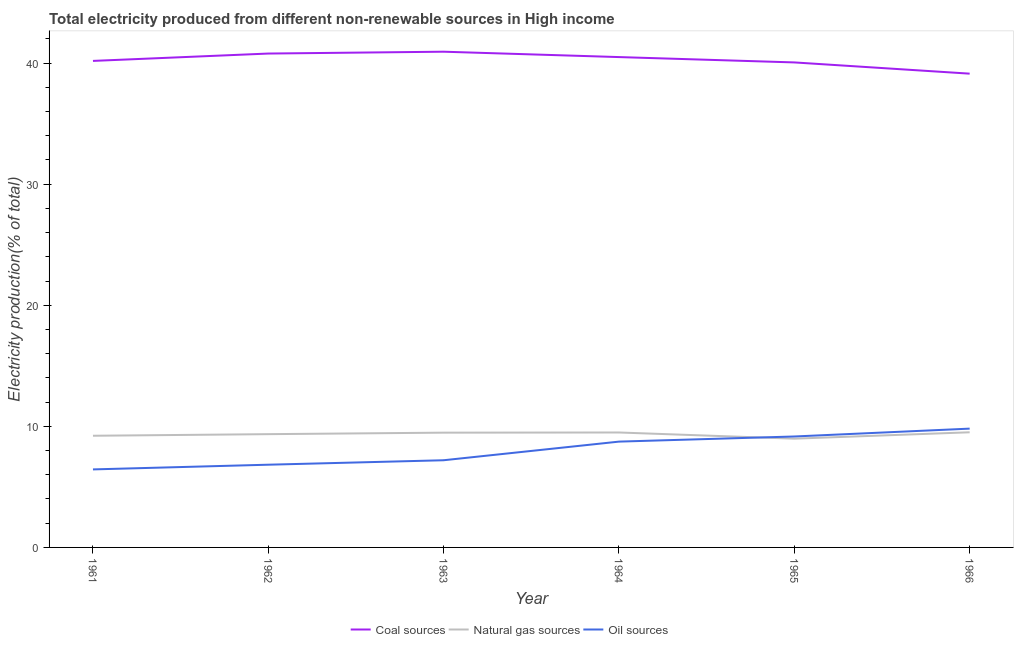What is the percentage of electricity produced by oil sources in 1964?
Your answer should be compact. 8.74. Across all years, what is the maximum percentage of electricity produced by natural gas?
Your answer should be compact. 9.51. Across all years, what is the minimum percentage of electricity produced by coal?
Your answer should be compact. 39.13. In which year was the percentage of electricity produced by coal maximum?
Offer a very short reply. 1963. In which year was the percentage of electricity produced by coal minimum?
Keep it short and to the point. 1966. What is the total percentage of electricity produced by natural gas in the graph?
Your answer should be compact. 56.04. What is the difference between the percentage of electricity produced by coal in 1965 and that in 1966?
Offer a terse response. 0.93. What is the difference between the percentage of electricity produced by natural gas in 1964 and the percentage of electricity produced by coal in 1966?
Offer a very short reply. -29.63. What is the average percentage of electricity produced by natural gas per year?
Offer a terse response. 9.34. In the year 1966, what is the difference between the percentage of electricity produced by coal and percentage of electricity produced by natural gas?
Your answer should be compact. 29.62. In how many years, is the percentage of electricity produced by oil sources greater than 40 %?
Your answer should be compact. 0. What is the ratio of the percentage of electricity produced by natural gas in 1961 to that in 1964?
Provide a succinct answer. 0.97. Is the difference between the percentage of electricity produced by natural gas in 1964 and 1966 greater than the difference between the percentage of electricity produced by coal in 1964 and 1966?
Offer a very short reply. No. What is the difference between the highest and the second highest percentage of electricity produced by natural gas?
Provide a succinct answer. 0.02. What is the difference between the highest and the lowest percentage of electricity produced by natural gas?
Provide a succinct answer. 0.53. In how many years, is the percentage of electricity produced by oil sources greater than the average percentage of electricity produced by oil sources taken over all years?
Keep it short and to the point. 3. Is it the case that in every year, the sum of the percentage of electricity produced by coal and percentage of electricity produced by natural gas is greater than the percentage of electricity produced by oil sources?
Provide a short and direct response. Yes. Does the percentage of electricity produced by natural gas monotonically increase over the years?
Keep it short and to the point. No. How many lines are there?
Make the answer very short. 3. How many years are there in the graph?
Your answer should be compact. 6. How many legend labels are there?
Your answer should be very brief. 3. How are the legend labels stacked?
Your answer should be compact. Horizontal. What is the title of the graph?
Your answer should be very brief. Total electricity produced from different non-renewable sources in High income. Does "Gaseous fuel" appear as one of the legend labels in the graph?
Offer a very short reply. No. What is the label or title of the X-axis?
Provide a short and direct response. Year. What is the Electricity production(% of total) in Coal sources in 1961?
Make the answer very short. 40.18. What is the Electricity production(% of total) of Natural gas sources in 1961?
Your answer should be compact. 9.22. What is the Electricity production(% of total) of Oil sources in 1961?
Offer a terse response. 6.44. What is the Electricity production(% of total) of Coal sources in 1962?
Your answer should be very brief. 40.79. What is the Electricity production(% of total) in Natural gas sources in 1962?
Provide a short and direct response. 9.35. What is the Electricity production(% of total) in Oil sources in 1962?
Ensure brevity in your answer.  6.83. What is the Electricity production(% of total) of Coal sources in 1963?
Your answer should be compact. 40.94. What is the Electricity production(% of total) in Natural gas sources in 1963?
Your answer should be compact. 9.48. What is the Electricity production(% of total) of Oil sources in 1963?
Your answer should be very brief. 7.2. What is the Electricity production(% of total) in Coal sources in 1964?
Your response must be concise. 40.5. What is the Electricity production(% of total) in Natural gas sources in 1964?
Make the answer very short. 9.49. What is the Electricity production(% of total) of Oil sources in 1964?
Your response must be concise. 8.74. What is the Electricity production(% of total) in Coal sources in 1965?
Provide a short and direct response. 40.05. What is the Electricity production(% of total) in Natural gas sources in 1965?
Provide a succinct answer. 8.98. What is the Electricity production(% of total) in Oil sources in 1965?
Your answer should be very brief. 9.16. What is the Electricity production(% of total) of Coal sources in 1966?
Provide a succinct answer. 39.13. What is the Electricity production(% of total) in Natural gas sources in 1966?
Give a very brief answer. 9.51. What is the Electricity production(% of total) of Oil sources in 1966?
Offer a terse response. 9.81. Across all years, what is the maximum Electricity production(% of total) of Coal sources?
Provide a succinct answer. 40.94. Across all years, what is the maximum Electricity production(% of total) in Natural gas sources?
Keep it short and to the point. 9.51. Across all years, what is the maximum Electricity production(% of total) in Oil sources?
Your answer should be compact. 9.81. Across all years, what is the minimum Electricity production(% of total) of Coal sources?
Provide a short and direct response. 39.13. Across all years, what is the minimum Electricity production(% of total) in Natural gas sources?
Keep it short and to the point. 8.98. Across all years, what is the minimum Electricity production(% of total) in Oil sources?
Your response must be concise. 6.44. What is the total Electricity production(% of total) in Coal sources in the graph?
Provide a short and direct response. 241.58. What is the total Electricity production(% of total) of Natural gas sources in the graph?
Give a very brief answer. 56.04. What is the total Electricity production(% of total) of Oil sources in the graph?
Offer a very short reply. 48.19. What is the difference between the Electricity production(% of total) of Coal sources in 1961 and that in 1962?
Your response must be concise. -0.61. What is the difference between the Electricity production(% of total) in Natural gas sources in 1961 and that in 1962?
Offer a terse response. -0.13. What is the difference between the Electricity production(% of total) in Oil sources in 1961 and that in 1962?
Give a very brief answer. -0.39. What is the difference between the Electricity production(% of total) of Coal sources in 1961 and that in 1963?
Your response must be concise. -0.76. What is the difference between the Electricity production(% of total) of Natural gas sources in 1961 and that in 1963?
Make the answer very short. -0.26. What is the difference between the Electricity production(% of total) of Oil sources in 1961 and that in 1963?
Your answer should be very brief. -0.76. What is the difference between the Electricity production(% of total) in Coal sources in 1961 and that in 1964?
Provide a succinct answer. -0.32. What is the difference between the Electricity production(% of total) of Natural gas sources in 1961 and that in 1964?
Your answer should be very brief. -0.27. What is the difference between the Electricity production(% of total) in Oil sources in 1961 and that in 1964?
Provide a short and direct response. -2.29. What is the difference between the Electricity production(% of total) in Coal sources in 1961 and that in 1965?
Make the answer very short. 0.13. What is the difference between the Electricity production(% of total) in Natural gas sources in 1961 and that in 1965?
Offer a very short reply. 0.24. What is the difference between the Electricity production(% of total) in Oil sources in 1961 and that in 1965?
Your answer should be very brief. -2.72. What is the difference between the Electricity production(% of total) of Coal sources in 1961 and that in 1966?
Offer a terse response. 1.05. What is the difference between the Electricity production(% of total) of Natural gas sources in 1961 and that in 1966?
Provide a short and direct response. -0.29. What is the difference between the Electricity production(% of total) of Oil sources in 1961 and that in 1966?
Make the answer very short. -3.37. What is the difference between the Electricity production(% of total) of Coal sources in 1962 and that in 1963?
Your answer should be compact. -0.15. What is the difference between the Electricity production(% of total) of Natural gas sources in 1962 and that in 1963?
Offer a terse response. -0.12. What is the difference between the Electricity production(% of total) in Oil sources in 1962 and that in 1963?
Make the answer very short. -0.37. What is the difference between the Electricity production(% of total) in Coal sources in 1962 and that in 1964?
Provide a short and direct response. 0.29. What is the difference between the Electricity production(% of total) of Natural gas sources in 1962 and that in 1964?
Your answer should be compact. -0.14. What is the difference between the Electricity production(% of total) of Oil sources in 1962 and that in 1964?
Provide a succinct answer. -1.91. What is the difference between the Electricity production(% of total) in Coal sources in 1962 and that in 1965?
Offer a terse response. 0.73. What is the difference between the Electricity production(% of total) of Natural gas sources in 1962 and that in 1965?
Ensure brevity in your answer.  0.37. What is the difference between the Electricity production(% of total) in Oil sources in 1962 and that in 1965?
Provide a succinct answer. -2.33. What is the difference between the Electricity production(% of total) in Coal sources in 1962 and that in 1966?
Your answer should be very brief. 1.66. What is the difference between the Electricity production(% of total) in Natural gas sources in 1962 and that in 1966?
Your answer should be very brief. -0.16. What is the difference between the Electricity production(% of total) in Oil sources in 1962 and that in 1966?
Make the answer very short. -2.98. What is the difference between the Electricity production(% of total) of Coal sources in 1963 and that in 1964?
Offer a terse response. 0.44. What is the difference between the Electricity production(% of total) of Natural gas sources in 1963 and that in 1964?
Provide a succinct answer. -0.01. What is the difference between the Electricity production(% of total) of Oil sources in 1963 and that in 1964?
Offer a very short reply. -1.54. What is the difference between the Electricity production(% of total) of Coal sources in 1963 and that in 1965?
Ensure brevity in your answer.  0.88. What is the difference between the Electricity production(% of total) of Natural gas sources in 1963 and that in 1965?
Ensure brevity in your answer.  0.5. What is the difference between the Electricity production(% of total) in Oil sources in 1963 and that in 1965?
Offer a terse response. -1.96. What is the difference between the Electricity production(% of total) in Coal sources in 1963 and that in 1966?
Your answer should be very brief. 1.81. What is the difference between the Electricity production(% of total) of Natural gas sources in 1963 and that in 1966?
Ensure brevity in your answer.  -0.03. What is the difference between the Electricity production(% of total) in Oil sources in 1963 and that in 1966?
Offer a very short reply. -2.61. What is the difference between the Electricity production(% of total) in Coal sources in 1964 and that in 1965?
Offer a very short reply. 0.44. What is the difference between the Electricity production(% of total) in Natural gas sources in 1964 and that in 1965?
Your answer should be very brief. 0.51. What is the difference between the Electricity production(% of total) of Oil sources in 1964 and that in 1965?
Give a very brief answer. -0.42. What is the difference between the Electricity production(% of total) of Coal sources in 1964 and that in 1966?
Give a very brief answer. 1.37. What is the difference between the Electricity production(% of total) of Natural gas sources in 1964 and that in 1966?
Ensure brevity in your answer.  -0.02. What is the difference between the Electricity production(% of total) in Oil sources in 1964 and that in 1966?
Offer a very short reply. -1.07. What is the difference between the Electricity production(% of total) in Coal sources in 1965 and that in 1966?
Provide a succinct answer. 0.93. What is the difference between the Electricity production(% of total) of Natural gas sources in 1965 and that in 1966?
Your answer should be very brief. -0.53. What is the difference between the Electricity production(% of total) in Oil sources in 1965 and that in 1966?
Ensure brevity in your answer.  -0.65. What is the difference between the Electricity production(% of total) in Coal sources in 1961 and the Electricity production(% of total) in Natural gas sources in 1962?
Your answer should be compact. 30.83. What is the difference between the Electricity production(% of total) of Coal sources in 1961 and the Electricity production(% of total) of Oil sources in 1962?
Your answer should be very brief. 33.35. What is the difference between the Electricity production(% of total) of Natural gas sources in 1961 and the Electricity production(% of total) of Oil sources in 1962?
Offer a terse response. 2.39. What is the difference between the Electricity production(% of total) of Coal sources in 1961 and the Electricity production(% of total) of Natural gas sources in 1963?
Give a very brief answer. 30.7. What is the difference between the Electricity production(% of total) in Coal sources in 1961 and the Electricity production(% of total) in Oil sources in 1963?
Make the answer very short. 32.98. What is the difference between the Electricity production(% of total) of Natural gas sources in 1961 and the Electricity production(% of total) of Oil sources in 1963?
Provide a short and direct response. 2.02. What is the difference between the Electricity production(% of total) of Coal sources in 1961 and the Electricity production(% of total) of Natural gas sources in 1964?
Provide a succinct answer. 30.69. What is the difference between the Electricity production(% of total) in Coal sources in 1961 and the Electricity production(% of total) in Oil sources in 1964?
Make the answer very short. 31.44. What is the difference between the Electricity production(% of total) of Natural gas sources in 1961 and the Electricity production(% of total) of Oil sources in 1964?
Provide a succinct answer. 0.48. What is the difference between the Electricity production(% of total) in Coal sources in 1961 and the Electricity production(% of total) in Natural gas sources in 1965?
Ensure brevity in your answer.  31.2. What is the difference between the Electricity production(% of total) of Coal sources in 1961 and the Electricity production(% of total) of Oil sources in 1965?
Provide a succinct answer. 31.02. What is the difference between the Electricity production(% of total) of Natural gas sources in 1961 and the Electricity production(% of total) of Oil sources in 1965?
Keep it short and to the point. 0.06. What is the difference between the Electricity production(% of total) in Coal sources in 1961 and the Electricity production(% of total) in Natural gas sources in 1966?
Ensure brevity in your answer.  30.67. What is the difference between the Electricity production(% of total) in Coal sources in 1961 and the Electricity production(% of total) in Oil sources in 1966?
Your response must be concise. 30.37. What is the difference between the Electricity production(% of total) in Natural gas sources in 1961 and the Electricity production(% of total) in Oil sources in 1966?
Provide a short and direct response. -0.59. What is the difference between the Electricity production(% of total) of Coal sources in 1962 and the Electricity production(% of total) of Natural gas sources in 1963?
Give a very brief answer. 31.31. What is the difference between the Electricity production(% of total) in Coal sources in 1962 and the Electricity production(% of total) in Oil sources in 1963?
Keep it short and to the point. 33.59. What is the difference between the Electricity production(% of total) of Natural gas sources in 1962 and the Electricity production(% of total) of Oil sources in 1963?
Offer a very short reply. 2.15. What is the difference between the Electricity production(% of total) in Coal sources in 1962 and the Electricity production(% of total) in Natural gas sources in 1964?
Offer a very short reply. 31.29. What is the difference between the Electricity production(% of total) in Coal sources in 1962 and the Electricity production(% of total) in Oil sources in 1964?
Your answer should be very brief. 32.05. What is the difference between the Electricity production(% of total) in Natural gas sources in 1962 and the Electricity production(% of total) in Oil sources in 1964?
Provide a succinct answer. 0.62. What is the difference between the Electricity production(% of total) in Coal sources in 1962 and the Electricity production(% of total) in Natural gas sources in 1965?
Keep it short and to the point. 31.81. What is the difference between the Electricity production(% of total) of Coal sources in 1962 and the Electricity production(% of total) of Oil sources in 1965?
Your answer should be very brief. 31.63. What is the difference between the Electricity production(% of total) in Natural gas sources in 1962 and the Electricity production(% of total) in Oil sources in 1965?
Give a very brief answer. 0.19. What is the difference between the Electricity production(% of total) of Coal sources in 1962 and the Electricity production(% of total) of Natural gas sources in 1966?
Provide a short and direct response. 31.28. What is the difference between the Electricity production(% of total) of Coal sources in 1962 and the Electricity production(% of total) of Oil sources in 1966?
Ensure brevity in your answer.  30.98. What is the difference between the Electricity production(% of total) of Natural gas sources in 1962 and the Electricity production(% of total) of Oil sources in 1966?
Give a very brief answer. -0.46. What is the difference between the Electricity production(% of total) of Coal sources in 1963 and the Electricity production(% of total) of Natural gas sources in 1964?
Your response must be concise. 31.45. What is the difference between the Electricity production(% of total) in Coal sources in 1963 and the Electricity production(% of total) in Oil sources in 1964?
Make the answer very short. 32.2. What is the difference between the Electricity production(% of total) in Natural gas sources in 1963 and the Electricity production(% of total) in Oil sources in 1964?
Provide a short and direct response. 0.74. What is the difference between the Electricity production(% of total) of Coal sources in 1963 and the Electricity production(% of total) of Natural gas sources in 1965?
Offer a very short reply. 31.96. What is the difference between the Electricity production(% of total) in Coal sources in 1963 and the Electricity production(% of total) in Oil sources in 1965?
Your answer should be very brief. 31.78. What is the difference between the Electricity production(% of total) in Natural gas sources in 1963 and the Electricity production(% of total) in Oil sources in 1965?
Give a very brief answer. 0.32. What is the difference between the Electricity production(% of total) of Coal sources in 1963 and the Electricity production(% of total) of Natural gas sources in 1966?
Give a very brief answer. 31.43. What is the difference between the Electricity production(% of total) of Coal sources in 1963 and the Electricity production(% of total) of Oil sources in 1966?
Make the answer very short. 31.13. What is the difference between the Electricity production(% of total) in Natural gas sources in 1963 and the Electricity production(% of total) in Oil sources in 1966?
Make the answer very short. -0.33. What is the difference between the Electricity production(% of total) in Coal sources in 1964 and the Electricity production(% of total) in Natural gas sources in 1965?
Keep it short and to the point. 31.51. What is the difference between the Electricity production(% of total) of Coal sources in 1964 and the Electricity production(% of total) of Oil sources in 1965?
Your response must be concise. 31.33. What is the difference between the Electricity production(% of total) of Natural gas sources in 1964 and the Electricity production(% of total) of Oil sources in 1965?
Your response must be concise. 0.33. What is the difference between the Electricity production(% of total) in Coal sources in 1964 and the Electricity production(% of total) in Natural gas sources in 1966?
Provide a succinct answer. 30.99. What is the difference between the Electricity production(% of total) in Coal sources in 1964 and the Electricity production(% of total) in Oil sources in 1966?
Keep it short and to the point. 30.68. What is the difference between the Electricity production(% of total) in Natural gas sources in 1964 and the Electricity production(% of total) in Oil sources in 1966?
Give a very brief answer. -0.32. What is the difference between the Electricity production(% of total) of Coal sources in 1965 and the Electricity production(% of total) of Natural gas sources in 1966?
Your response must be concise. 30.55. What is the difference between the Electricity production(% of total) in Coal sources in 1965 and the Electricity production(% of total) in Oil sources in 1966?
Offer a very short reply. 30.24. What is the difference between the Electricity production(% of total) in Natural gas sources in 1965 and the Electricity production(% of total) in Oil sources in 1966?
Make the answer very short. -0.83. What is the average Electricity production(% of total) in Coal sources per year?
Your answer should be compact. 40.26. What is the average Electricity production(% of total) in Natural gas sources per year?
Give a very brief answer. 9.34. What is the average Electricity production(% of total) of Oil sources per year?
Offer a terse response. 8.03. In the year 1961, what is the difference between the Electricity production(% of total) in Coal sources and Electricity production(% of total) in Natural gas sources?
Provide a short and direct response. 30.96. In the year 1961, what is the difference between the Electricity production(% of total) in Coal sources and Electricity production(% of total) in Oil sources?
Make the answer very short. 33.74. In the year 1961, what is the difference between the Electricity production(% of total) in Natural gas sources and Electricity production(% of total) in Oil sources?
Your response must be concise. 2.78. In the year 1962, what is the difference between the Electricity production(% of total) in Coal sources and Electricity production(% of total) in Natural gas sources?
Your answer should be very brief. 31.43. In the year 1962, what is the difference between the Electricity production(% of total) in Coal sources and Electricity production(% of total) in Oil sources?
Offer a terse response. 33.96. In the year 1962, what is the difference between the Electricity production(% of total) of Natural gas sources and Electricity production(% of total) of Oil sources?
Keep it short and to the point. 2.52. In the year 1963, what is the difference between the Electricity production(% of total) of Coal sources and Electricity production(% of total) of Natural gas sources?
Offer a terse response. 31.46. In the year 1963, what is the difference between the Electricity production(% of total) of Coal sources and Electricity production(% of total) of Oil sources?
Offer a terse response. 33.74. In the year 1963, what is the difference between the Electricity production(% of total) in Natural gas sources and Electricity production(% of total) in Oil sources?
Provide a short and direct response. 2.28. In the year 1964, what is the difference between the Electricity production(% of total) in Coal sources and Electricity production(% of total) in Natural gas sources?
Offer a terse response. 31. In the year 1964, what is the difference between the Electricity production(% of total) in Coal sources and Electricity production(% of total) in Oil sources?
Your answer should be compact. 31.76. In the year 1964, what is the difference between the Electricity production(% of total) of Natural gas sources and Electricity production(% of total) of Oil sources?
Give a very brief answer. 0.75. In the year 1965, what is the difference between the Electricity production(% of total) in Coal sources and Electricity production(% of total) in Natural gas sources?
Your answer should be very brief. 31.07. In the year 1965, what is the difference between the Electricity production(% of total) of Coal sources and Electricity production(% of total) of Oil sources?
Provide a short and direct response. 30.89. In the year 1965, what is the difference between the Electricity production(% of total) of Natural gas sources and Electricity production(% of total) of Oil sources?
Make the answer very short. -0.18. In the year 1966, what is the difference between the Electricity production(% of total) of Coal sources and Electricity production(% of total) of Natural gas sources?
Offer a terse response. 29.62. In the year 1966, what is the difference between the Electricity production(% of total) of Coal sources and Electricity production(% of total) of Oil sources?
Keep it short and to the point. 29.32. In the year 1966, what is the difference between the Electricity production(% of total) in Natural gas sources and Electricity production(% of total) in Oil sources?
Your response must be concise. -0.3. What is the ratio of the Electricity production(% of total) in Coal sources in 1961 to that in 1962?
Make the answer very short. 0.99. What is the ratio of the Electricity production(% of total) of Natural gas sources in 1961 to that in 1962?
Give a very brief answer. 0.99. What is the ratio of the Electricity production(% of total) in Oil sources in 1961 to that in 1962?
Provide a succinct answer. 0.94. What is the ratio of the Electricity production(% of total) of Coal sources in 1961 to that in 1963?
Keep it short and to the point. 0.98. What is the ratio of the Electricity production(% of total) of Natural gas sources in 1961 to that in 1963?
Make the answer very short. 0.97. What is the ratio of the Electricity production(% of total) in Oil sources in 1961 to that in 1963?
Offer a terse response. 0.89. What is the ratio of the Electricity production(% of total) of Coal sources in 1961 to that in 1964?
Offer a very short reply. 0.99. What is the ratio of the Electricity production(% of total) of Natural gas sources in 1961 to that in 1964?
Your response must be concise. 0.97. What is the ratio of the Electricity production(% of total) in Oil sources in 1961 to that in 1964?
Your response must be concise. 0.74. What is the ratio of the Electricity production(% of total) of Natural gas sources in 1961 to that in 1965?
Your answer should be compact. 1.03. What is the ratio of the Electricity production(% of total) in Oil sources in 1961 to that in 1965?
Ensure brevity in your answer.  0.7. What is the ratio of the Electricity production(% of total) of Coal sources in 1961 to that in 1966?
Ensure brevity in your answer.  1.03. What is the ratio of the Electricity production(% of total) of Natural gas sources in 1961 to that in 1966?
Ensure brevity in your answer.  0.97. What is the ratio of the Electricity production(% of total) of Oil sources in 1961 to that in 1966?
Give a very brief answer. 0.66. What is the ratio of the Electricity production(% of total) in Coal sources in 1962 to that in 1963?
Make the answer very short. 1. What is the ratio of the Electricity production(% of total) of Natural gas sources in 1962 to that in 1963?
Provide a short and direct response. 0.99. What is the ratio of the Electricity production(% of total) of Oil sources in 1962 to that in 1963?
Make the answer very short. 0.95. What is the ratio of the Electricity production(% of total) of Natural gas sources in 1962 to that in 1964?
Offer a terse response. 0.99. What is the ratio of the Electricity production(% of total) in Oil sources in 1962 to that in 1964?
Give a very brief answer. 0.78. What is the ratio of the Electricity production(% of total) in Coal sources in 1962 to that in 1965?
Offer a very short reply. 1.02. What is the ratio of the Electricity production(% of total) in Natural gas sources in 1962 to that in 1965?
Keep it short and to the point. 1.04. What is the ratio of the Electricity production(% of total) in Oil sources in 1962 to that in 1965?
Make the answer very short. 0.75. What is the ratio of the Electricity production(% of total) in Coal sources in 1962 to that in 1966?
Keep it short and to the point. 1.04. What is the ratio of the Electricity production(% of total) of Natural gas sources in 1962 to that in 1966?
Provide a short and direct response. 0.98. What is the ratio of the Electricity production(% of total) of Oil sources in 1962 to that in 1966?
Ensure brevity in your answer.  0.7. What is the ratio of the Electricity production(% of total) in Coal sources in 1963 to that in 1964?
Give a very brief answer. 1.01. What is the ratio of the Electricity production(% of total) of Oil sources in 1963 to that in 1964?
Keep it short and to the point. 0.82. What is the ratio of the Electricity production(% of total) in Coal sources in 1963 to that in 1965?
Your answer should be very brief. 1.02. What is the ratio of the Electricity production(% of total) in Natural gas sources in 1963 to that in 1965?
Offer a terse response. 1.06. What is the ratio of the Electricity production(% of total) in Oil sources in 1963 to that in 1965?
Your answer should be compact. 0.79. What is the ratio of the Electricity production(% of total) in Coal sources in 1963 to that in 1966?
Offer a terse response. 1.05. What is the ratio of the Electricity production(% of total) in Natural gas sources in 1963 to that in 1966?
Offer a very short reply. 1. What is the ratio of the Electricity production(% of total) of Oil sources in 1963 to that in 1966?
Your answer should be compact. 0.73. What is the ratio of the Electricity production(% of total) of Natural gas sources in 1964 to that in 1965?
Ensure brevity in your answer.  1.06. What is the ratio of the Electricity production(% of total) of Oil sources in 1964 to that in 1965?
Give a very brief answer. 0.95. What is the ratio of the Electricity production(% of total) in Coal sources in 1964 to that in 1966?
Your response must be concise. 1.03. What is the ratio of the Electricity production(% of total) of Oil sources in 1964 to that in 1966?
Provide a succinct answer. 0.89. What is the ratio of the Electricity production(% of total) of Coal sources in 1965 to that in 1966?
Make the answer very short. 1.02. What is the ratio of the Electricity production(% of total) in Natural gas sources in 1965 to that in 1966?
Your answer should be very brief. 0.94. What is the ratio of the Electricity production(% of total) in Oil sources in 1965 to that in 1966?
Provide a short and direct response. 0.93. What is the difference between the highest and the second highest Electricity production(% of total) of Coal sources?
Your answer should be very brief. 0.15. What is the difference between the highest and the second highest Electricity production(% of total) of Natural gas sources?
Offer a very short reply. 0.02. What is the difference between the highest and the second highest Electricity production(% of total) of Oil sources?
Your response must be concise. 0.65. What is the difference between the highest and the lowest Electricity production(% of total) in Coal sources?
Make the answer very short. 1.81. What is the difference between the highest and the lowest Electricity production(% of total) in Natural gas sources?
Keep it short and to the point. 0.53. What is the difference between the highest and the lowest Electricity production(% of total) of Oil sources?
Provide a short and direct response. 3.37. 